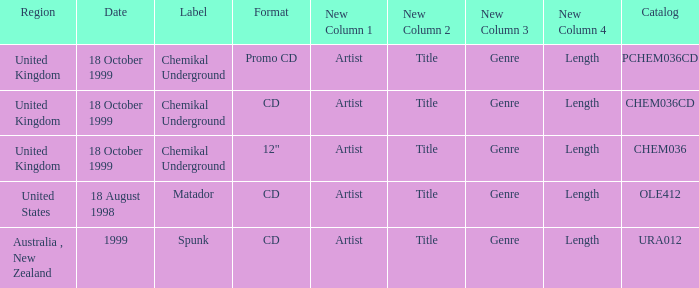What label has a catalog of chem036cd? Chemikal Underground. 